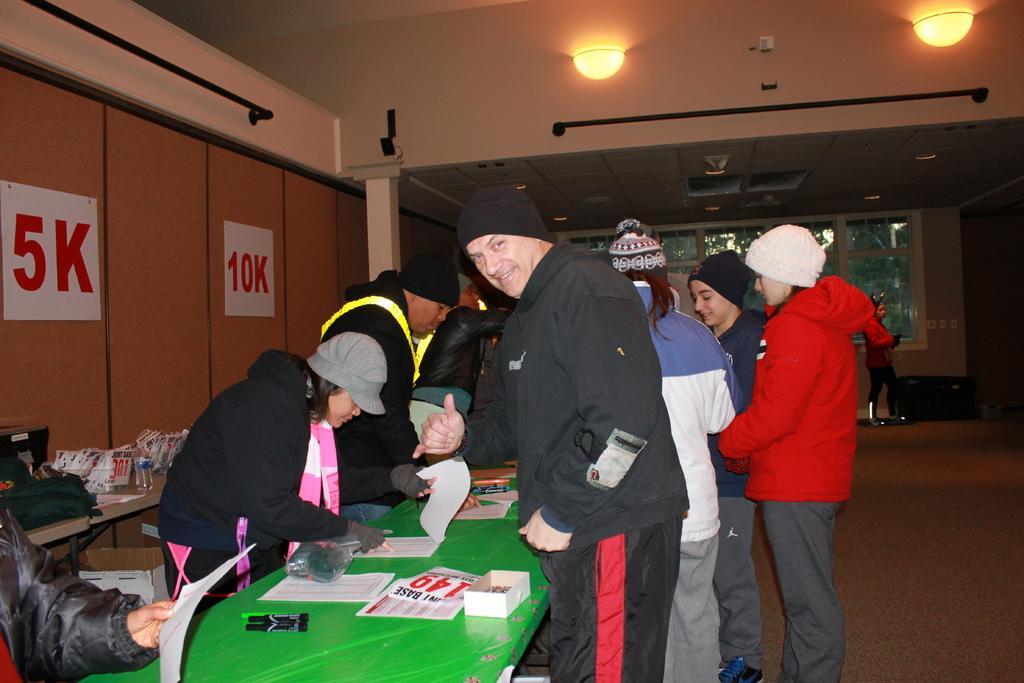Please provide a concise description of this image. In the center of the image we can see many persons at the table. On the table we can see books, papers. On the left side of the image we can see posts on the wall. In the background we can see windows, persons and wall. 